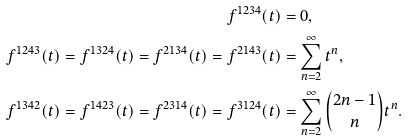Convert formula to latex. <formula><loc_0><loc_0><loc_500><loc_500>f ^ { 1 2 3 4 } ( t ) & = 0 , \\ f ^ { 1 2 4 3 } ( t ) = f ^ { 1 3 2 4 } ( t ) = f ^ { 2 1 3 4 } ( t ) = f ^ { 2 1 4 3 } ( t ) & = \sum _ { n = 2 } ^ { \infty } t ^ { n } , \\ f ^ { 1 3 4 2 } ( t ) = f ^ { 1 4 2 3 } ( t ) = f ^ { 2 3 1 4 } ( t ) = f ^ { 3 1 2 4 } ( t ) & = \sum _ { n = 2 } ^ { \infty } \binom { 2 n - 1 } { n } t ^ { n } .</formula> 